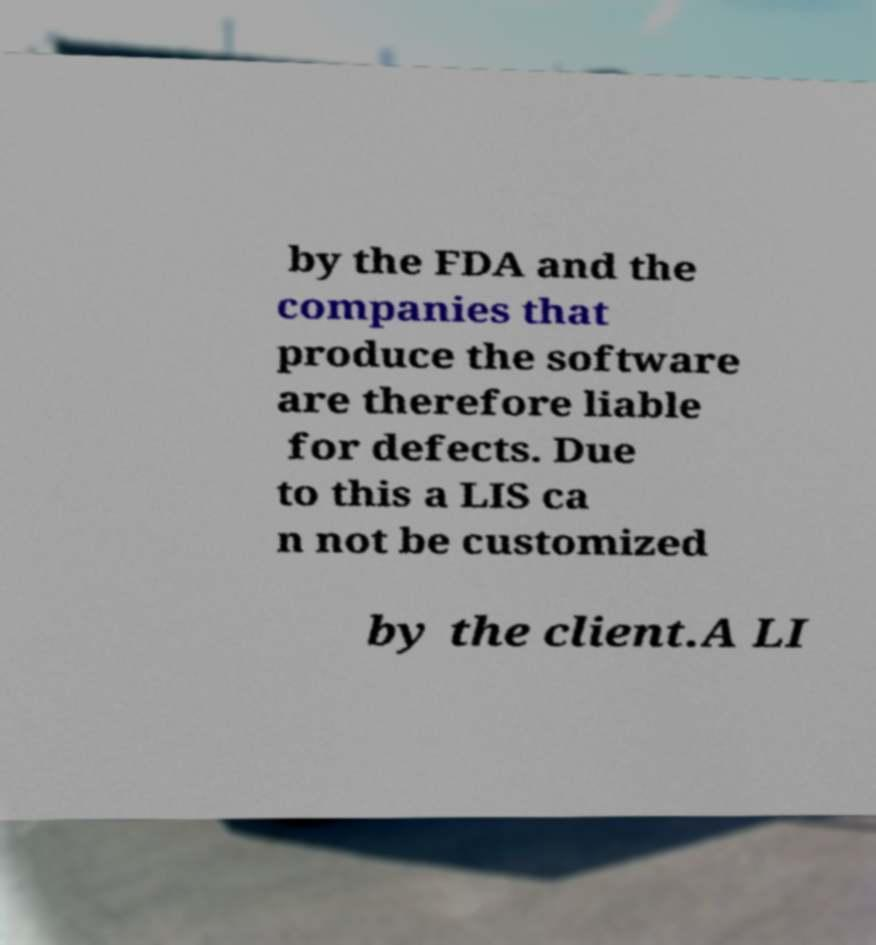Please identify and transcribe the text found in this image. by the FDA and the companies that produce the software are therefore liable for defects. Due to this a LIS ca n not be customized by the client.A LI 